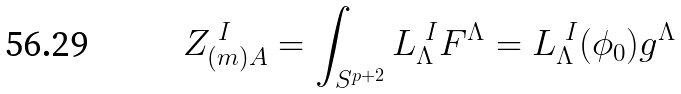Convert formula to latex. <formula><loc_0><loc_0><loc_500><loc_500>Z _ { ( m ) A } ^ { \ I } = \int _ { S ^ { p + 2 } } L _ { \Lambda } ^ { \ I } F ^ { \Lambda } = L _ { \Lambda } ^ { \ I } ( \phi _ { 0 } ) g ^ { \Lambda }</formula> 